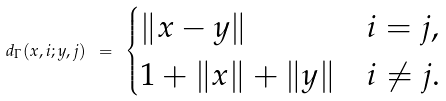<formula> <loc_0><loc_0><loc_500><loc_500>d _ { \Gamma } ( x , i ; y , j ) \ = \ \begin{cases} \| x - y \| & i = j , \\ 1 + \| x \| + \| y \| & i \neq j . \end{cases}</formula> 